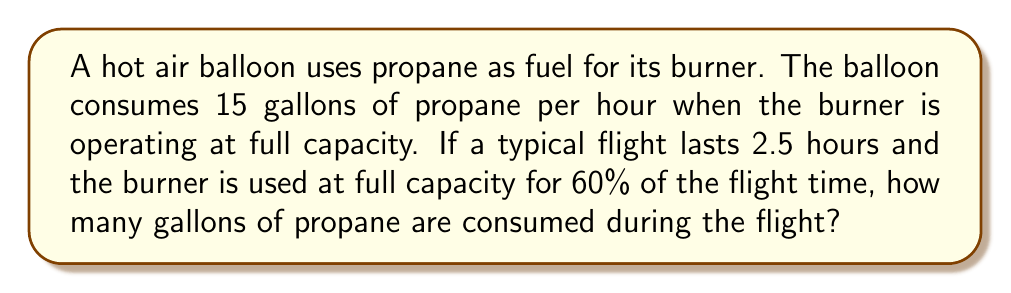What is the answer to this math problem? Let's break this problem down step-by-step:

1. Calculate the total flight time in hours:
   $$ \text{Total flight time} = 2.5 \text{ hours} $$

2. Determine the time the burner is used at full capacity:
   $$ \text{Burner time} = 60\% \text{ of total flight time} $$
   $$ \text{Burner time} = 0.60 \times 2.5 \text{ hours} = 1.5 \text{ hours} $$

3. Calculate the fuel consumption rate:
   $$ \text{Fuel consumption rate} = 15 \text{ gallons per hour} $$

4. Compute the total fuel consumed:
   $$ \text{Total fuel consumed} = \text{Burner time} \times \text{Fuel consumption rate} $$
   $$ \text{Total fuel consumed} = 1.5 \text{ hours} \times 15 \text{ gallons/hour} = 22.5 \text{ gallons} $$

Therefore, the hot air balloon consumes 22.5 gallons of propane during the 2.5-hour flight.
Answer: 22.5 gallons 